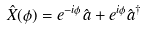Convert formula to latex. <formula><loc_0><loc_0><loc_500><loc_500>\hat { X } ( \phi ) = e ^ { - i \phi } \hat { a } + e ^ { i \phi } \hat { a } ^ { \dagger }</formula> 